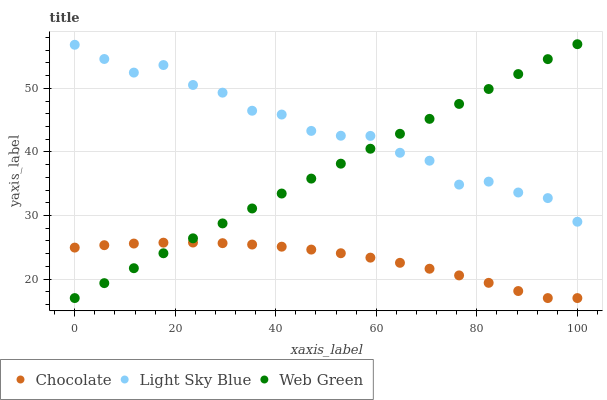Does Chocolate have the minimum area under the curve?
Answer yes or no. Yes. Does Light Sky Blue have the maximum area under the curve?
Answer yes or no. Yes. Does Web Green have the minimum area under the curve?
Answer yes or no. No. Does Web Green have the maximum area under the curve?
Answer yes or no. No. Is Web Green the smoothest?
Answer yes or no. Yes. Is Light Sky Blue the roughest?
Answer yes or no. Yes. Is Chocolate the smoothest?
Answer yes or no. No. Is Chocolate the roughest?
Answer yes or no. No. Does Web Green have the lowest value?
Answer yes or no. Yes. Does Web Green have the highest value?
Answer yes or no. Yes. Does Chocolate have the highest value?
Answer yes or no. No. Is Chocolate less than Light Sky Blue?
Answer yes or no. Yes. Is Light Sky Blue greater than Chocolate?
Answer yes or no. Yes. Does Light Sky Blue intersect Web Green?
Answer yes or no. Yes. Is Light Sky Blue less than Web Green?
Answer yes or no. No. Is Light Sky Blue greater than Web Green?
Answer yes or no. No. Does Chocolate intersect Light Sky Blue?
Answer yes or no. No. 